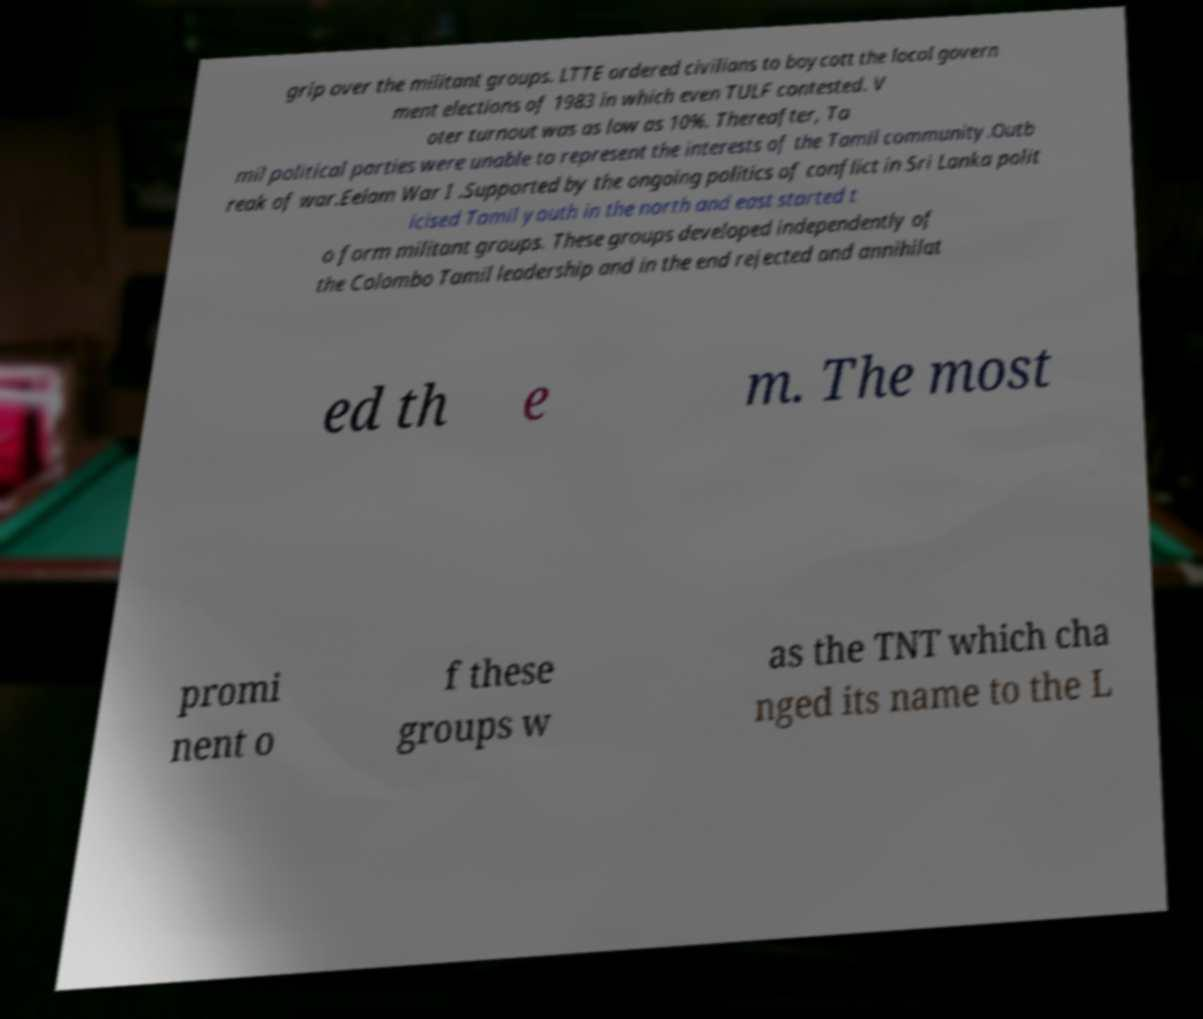Can you accurately transcribe the text from the provided image for me? grip over the militant groups. LTTE ordered civilians to boycott the local govern ment elections of 1983 in which even TULF contested. V oter turnout was as low as 10%. Thereafter, Ta mil political parties were unable to represent the interests of the Tamil community.Outb reak of war.Eelam War I .Supported by the ongoing politics of conflict in Sri Lanka polit icised Tamil youth in the north and east started t o form militant groups. These groups developed independently of the Colombo Tamil leadership and in the end rejected and annihilat ed th e m. The most promi nent o f these groups w as the TNT which cha nged its name to the L 